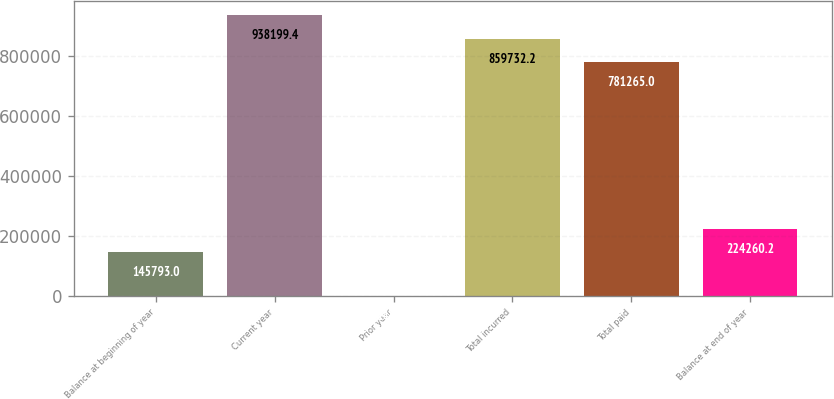Convert chart. <chart><loc_0><loc_0><loc_500><loc_500><bar_chart><fcel>Balance at beginning of year<fcel>Current year<fcel>Prior year<fcel>Total incurred<fcel>Total paid<fcel>Balance at end of year<nl><fcel>145793<fcel>938199<fcel>1448<fcel>859732<fcel>781265<fcel>224260<nl></chart> 